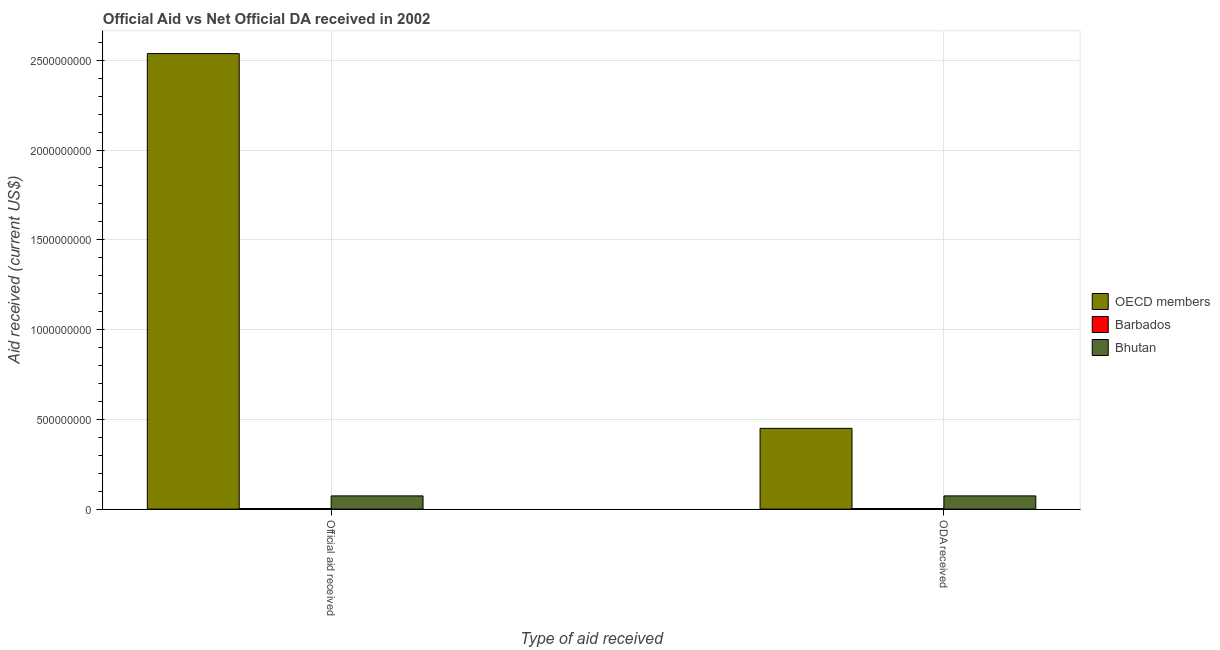How many different coloured bars are there?
Provide a short and direct response. 3. How many groups of bars are there?
Offer a very short reply. 2. Are the number of bars on each tick of the X-axis equal?
Give a very brief answer. Yes. How many bars are there on the 2nd tick from the left?
Provide a succinct answer. 3. How many bars are there on the 1st tick from the right?
Provide a short and direct response. 3. What is the label of the 1st group of bars from the left?
Provide a succinct answer. Official aid received. What is the official aid received in Bhutan?
Your response must be concise. 7.36e+07. Across all countries, what is the maximum official aid received?
Make the answer very short. 2.54e+09. Across all countries, what is the minimum oda received?
Offer a terse response. 3.31e+06. In which country was the oda received minimum?
Keep it short and to the point. Barbados. What is the total official aid received in the graph?
Offer a very short reply. 2.61e+09. What is the difference between the oda received in OECD members and that in Barbados?
Provide a short and direct response. 4.46e+08. What is the difference between the oda received in Barbados and the official aid received in Bhutan?
Keep it short and to the point. -7.03e+07. What is the average official aid received per country?
Your answer should be very brief. 8.71e+08. What is the difference between the official aid received and oda received in Bhutan?
Offer a terse response. 0. In how many countries, is the official aid received greater than 1100000000 US$?
Provide a short and direct response. 1. What is the ratio of the official aid received in Bhutan to that in Barbados?
Ensure brevity in your answer.  22.23. In how many countries, is the official aid received greater than the average official aid received taken over all countries?
Give a very brief answer. 1. What does the 2nd bar from the left in Official aid received represents?
Offer a very short reply. Barbados. Are all the bars in the graph horizontal?
Give a very brief answer. No. How many countries are there in the graph?
Your response must be concise. 3. Are the values on the major ticks of Y-axis written in scientific E-notation?
Offer a terse response. No. Does the graph contain grids?
Give a very brief answer. Yes. Where does the legend appear in the graph?
Your answer should be compact. Center right. How many legend labels are there?
Provide a short and direct response. 3. What is the title of the graph?
Give a very brief answer. Official Aid vs Net Official DA received in 2002 . Does "Uzbekistan" appear as one of the legend labels in the graph?
Give a very brief answer. No. What is the label or title of the X-axis?
Provide a succinct answer. Type of aid received. What is the label or title of the Y-axis?
Make the answer very short. Aid received (current US$). What is the Aid received (current US$) of OECD members in Official aid received?
Offer a very short reply. 2.54e+09. What is the Aid received (current US$) in Barbados in Official aid received?
Give a very brief answer. 3.31e+06. What is the Aid received (current US$) in Bhutan in Official aid received?
Offer a very short reply. 7.36e+07. What is the Aid received (current US$) of OECD members in ODA received?
Keep it short and to the point. 4.50e+08. What is the Aid received (current US$) in Barbados in ODA received?
Offer a terse response. 3.31e+06. What is the Aid received (current US$) of Bhutan in ODA received?
Provide a succinct answer. 7.36e+07. Across all Type of aid received, what is the maximum Aid received (current US$) in OECD members?
Provide a short and direct response. 2.54e+09. Across all Type of aid received, what is the maximum Aid received (current US$) of Barbados?
Ensure brevity in your answer.  3.31e+06. Across all Type of aid received, what is the maximum Aid received (current US$) of Bhutan?
Your response must be concise. 7.36e+07. Across all Type of aid received, what is the minimum Aid received (current US$) in OECD members?
Make the answer very short. 4.50e+08. Across all Type of aid received, what is the minimum Aid received (current US$) in Barbados?
Make the answer very short. 3.31e+06. Across all Type of aid received, what is the minimum Aid received (current US$) in Bhutan?
Provide a succinct answer. 7.36e+07. What is the total Aid received (current US$) in OECD members in the graph?
Ensure brevity in your answer.  2.99e+09. What is the total Aid received (current US$) in Barbados in the graph?
Offer a very short reply. 6.62e+06. What is the total Aid received (current US$) in Bhutan in the graph?
Keep it short and to the point. 1.47e+08. What is the difference between the Aid received (current US$) of OECD members in Official aid received and that in ODA received?
Make the answer very short. 2.09e+09. What is the difference between the Aid received (current US$) in Barbados in Official aid received and that in ODA received?
Provide a short and direct response. 0. What is the difference between the Aid received (current US$) of Bhutan in Official aid received and that in ODA received?
Your answer should be very brief. 0. What is the difference between the Aid received (current US$) of OECD members in Official aid received and the Aid received (current US$) of Barbados in ODA received?
Give a very brief answer. 2.53e+09. What is the difference between the Aid received (current US$) in OECD members in Official aid received and the Aid received (current US$) in Bhutan in ODA received?
Your answer should be compact. 2.46e+09. What is the difference between the Aid received (current US$) in Barbados in Official aid received and the Aid received (current US$) in Bhutan in ODA received?
Keep it short and to the point. -7.03e+07. What is the average Aid received (current US$) of OECD members per Type of aid received?
Offer a very short reply. 1.49e+09. What is the average Aid received (current US$) of Barbados per Type of aid received?
Keep it short and to the point. 3.31e+06. What is the average Aid received (current US$) of Bhutan per Type of aid received?
Provide a short and direct response. 7.36e+07. What is the difference between the Aid received (current US$) in OECD members and Aid received (current US$) in Barbados in Official aid received?
Offer a very short reply. 2.53e+09. What is the difference between the Aid received (current US$) of OECD members and Aid received (current US$) of Bhutan in Official aid received?
Make the answer very short. 2.46e+09. What is the difference between the Aid received (current US$) of Barbados and Aid received (current US$) of Bhutan in Official aid received?
Provide a short and direct response. -7.03e+07. What is the difference between the Aid received (current US$) in OECD members and Aid received (current US$) in Barbados in ODA received?
Your answer should be very brief. 4.46e+08. What is the difference between the Aid received (current US$) in OECD members and Aid received (current US$) in Bhutan in ODA received?
Offer a very short reply. 3.76e+08. What is the difference between the Aid received (current US$) of Barbados and Aid received (current US$) of Bhutan in ODA received?
Offer a terse response. -7.03e+07. What is the ratio of the Aid received (current US$) of OECD members in Official aid received to that in ODA received?
Offer a very short reply. 5.64. What is the ratio of the Aid received (current US$) of Barbados in Official aid received to that in ODA received?
Offer a very short reply. 1. What is the difference between the highest and the second highest Aid received (current US$) in OECD members?
Provide a short and direct response. 2.09e+09. What is the difference between the highest and the second highest Aid received (current US$) in Barbados?
Your response must be concise. 0. What is the difference between the highest and the lowest Aid received (current US$) in OECD members?
Make the answer very short. 2.09e+09. What is the difference between the highest and the lowest Aid received (current US$) in Barbados?
Your response must be concise. 0. What is the difference between the highest and the lowest Aid received (current US$) in Bhutan?
Keep it short and to the point. 0. 